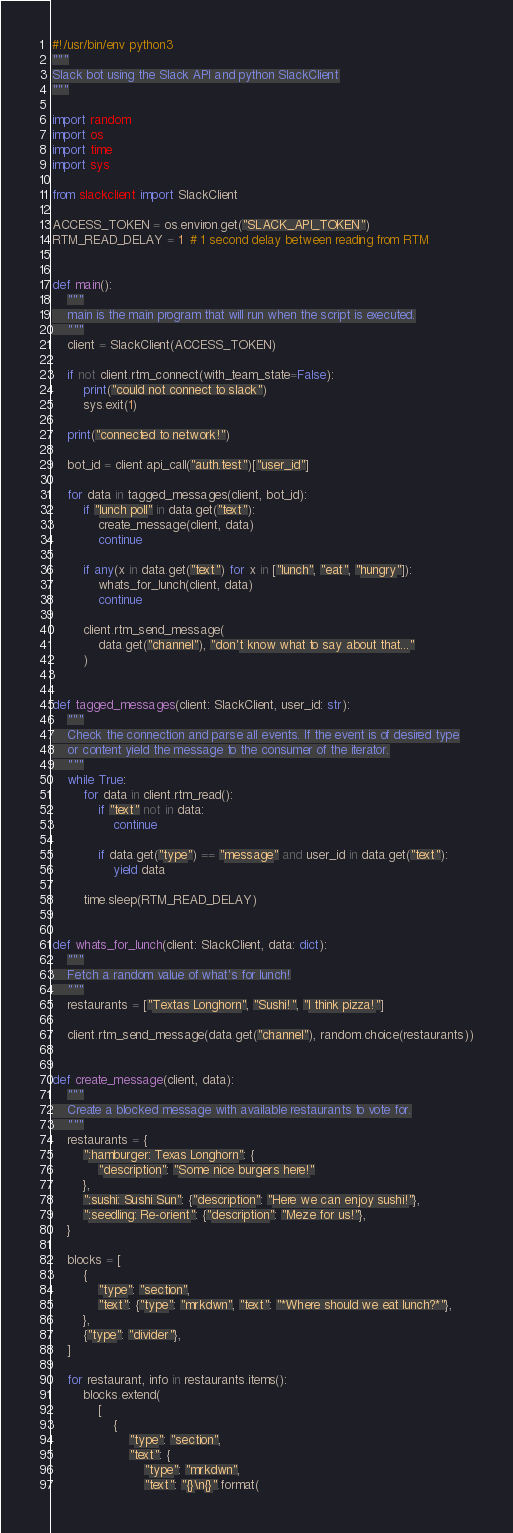<code> <loc_0><loc_0><loc_500><loc_500><_Python_>#!/usr/bin/env python3
"""
Slack bot using the Slack API and python SlackClient
"""

import random
import os
import time
import sys

from slackclient import SlackClient

ACCESS_TOKEN = os.environ.get("SLACK_API_TOKEN")
RTM_READ_DELAY = 1  # 1 second delay between reading from RTM


def main():
    """
    main is the main program that will run when the script is executed.
    """
    client = SlackClient(ACCESS_TOKEN)

    if not client.rtm_connect(with_team_state=False):
        print("could not connect to slack")
        sys.exit(1)

    print("connected to network!")

    bot_id = client.api_call("auth.test")["user_id"]

    for data in tagged_messages(client, bot_id):
        if "lunch poll" in data.get("text"):
            create_message(client, data)
            continue

        if any(x in data.get("text") for x in ["lunch", "eat", "hungry"]):
            whats_for_lunch(client, data)
            continue

        client.rtm_send_message(
            data.get("channel"), "don't know what to say about that..."
        )


def tagged_messages(client: SlackClient, user_id: str):
    """
    Check the connection and parse all events. If the event is of desired type
    or content yield the message to the consumer of the iterator.
    """
    while True:
        for data in client.rtm_read():
            if "text" not in data:
                continue

            if data.get("type") == "message" and user_id in data.get("text"):
                yield data

        time.sleep(RTM_READ_DELAY)


def whats_for_lunch(client: SlackClient, data: dict):
    """
    Fetch a random value of what's for lunch!
    """
    restaurants = ["Textas Longhorn", "Sushi!", "I think pizza!"]

    client.rtm_send_message(data.get("channel"), random.choice(restaurants))


def create_message(client, data):
    """
    Create a blocked message with available restaurants to vote for.
    """
    restaurants = {
        ":hamburger: Texas Longhorn": {
            "description": "Some nice burgers here!"
        },
        ":sushi: Sushi Sun": {"description": "Here we can enjoy sushi!"},
        ":seedling: Re-orient": {"description": "Meze for us!"},
    }

    blocks = [
        {
            "type": "section",
            "text": {"type": "mrkdwn", "text": "*Where should we eat lunch?*"},
        },
        {"type": "divider"},
    ]

    for restaurant, info in restaurants.items():
        blocks.extend(
            [
                {
                    "type": "section",
                    "text": {
                        "type": "mrkdwn",
                        "text": "{}\n{}".format(</code> 